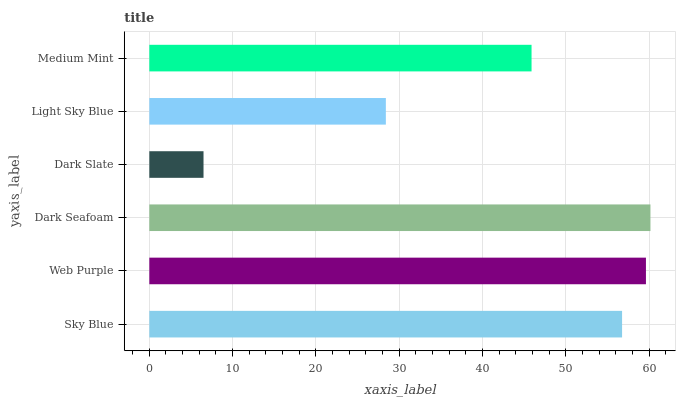Is Dark Slate the minimum?
Answer yes or no. Yes. Is Dark Seafoam the maximum?
Answer yes or no. Yes. Is Web Purple the minimum?
Answer yes or no. No. Is Web Purple the maximum?
Answer yes or no. No. Is Web Purple greater than Sky Blue?
Answer yes or no. Yes. Is Sky Blue less than Web Purple?
Answer yes or no. Yes. Is Sky Blue greater than Web Purple?
Answer yes or no. No. Is Web Purple less than Sky Blue?
Answer yes or no. No. Is Sky Blue the high median?
Answer yes or no. Yes. Is Medium Mint the low median?
Answer yes or no. Yes. Is Dark Seafoam the high median?
Answer yes or no. No. Is Web Purple the low median?
Answer yes or no. No. 